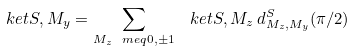Convert formula to latex. <formula><loc_0><loc_0><loc_500><loc_500>\ k e t { S , M _ { y } } = \sum _ { M _ { z } \ m e q 0 , \pm 1 } \, \ k e t { S , M _ { z } } \, d ^ { S } _ { M _ { z } , M _ { y } } ( \pi / 2 )</formula> 